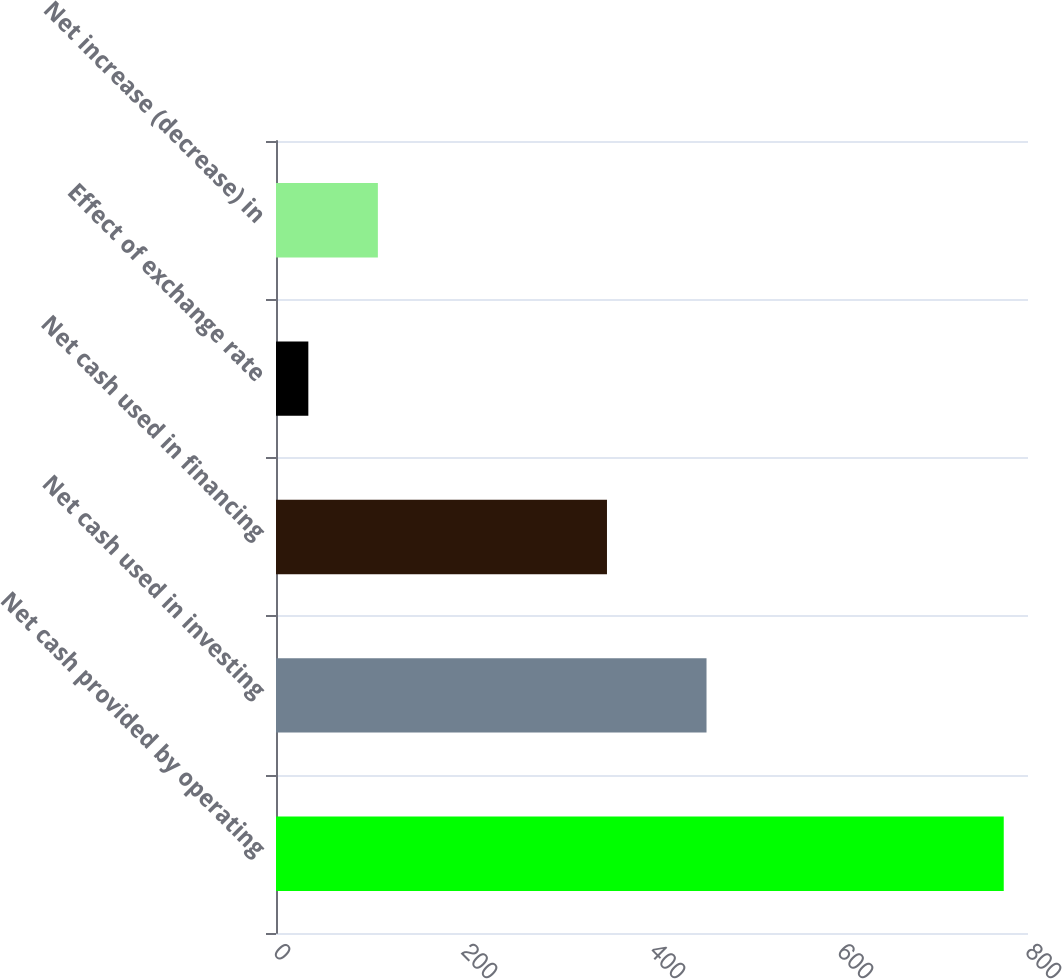<chart> <loc_0><loc_0><loc_500><loc_500><bar_chart><fcel>Net cash provided by operating<fcel>Net cash used in investing<fcel>Net cash used in financing<fcel>Effect of exchange rate<fcel>Net increase (decrease) in<nl><fcel>774.2<fcel>458<fcel>352.1<fcel>34.4<fcel>108.38<nl></chart> 